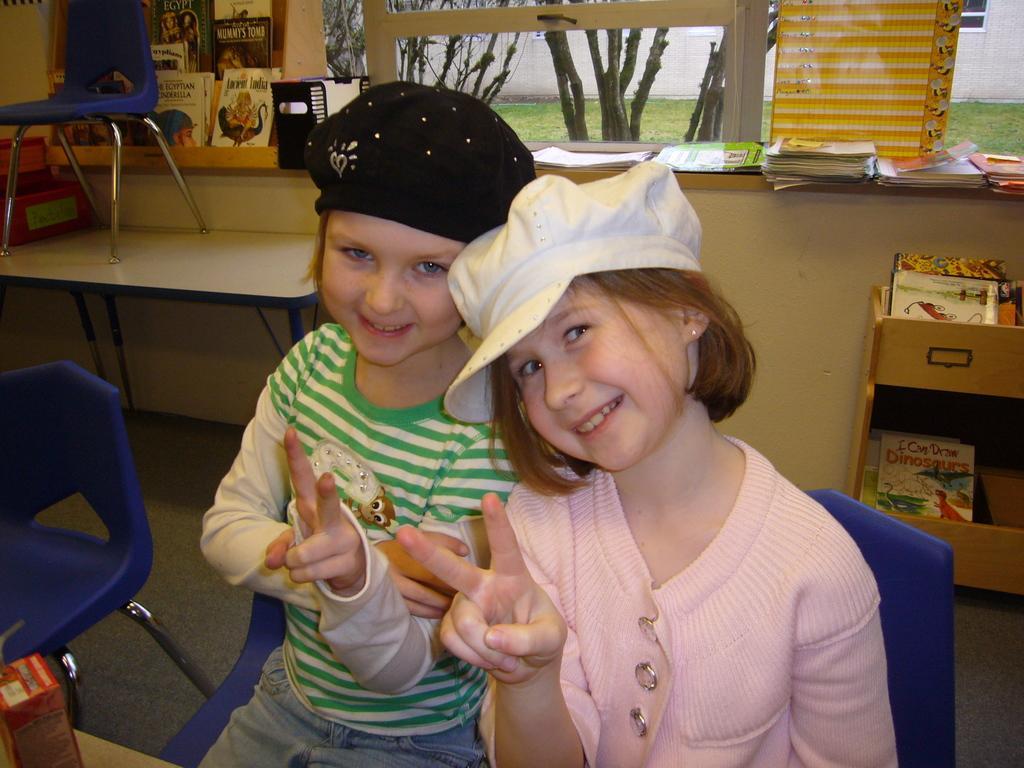Can you describe this image briefly? In the picture we can find a two children sitting on a chair beside them there is one more chair which is blue in colour. In the background we can find a window from the window we can find a grass, trees and we can also find a wall, one chair on the table which is also blue in colour. And we can find some books on the window. And the two children are wearing a cap. 